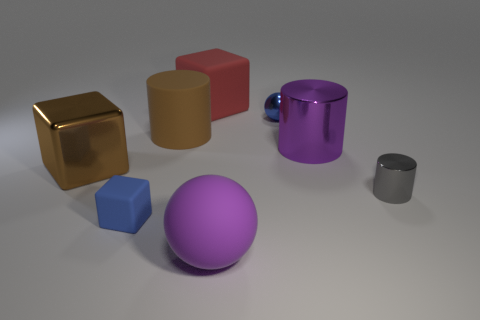There is a big purple object that is made of the same material as the tiny gray object; what is its shape? The large purple object shares its smooth, matte surface appearance with the small gray object, which suggests that they're made of the same material. Its shape is a perfect sphere, exemplifying symmetry and balance in three dimensions. 